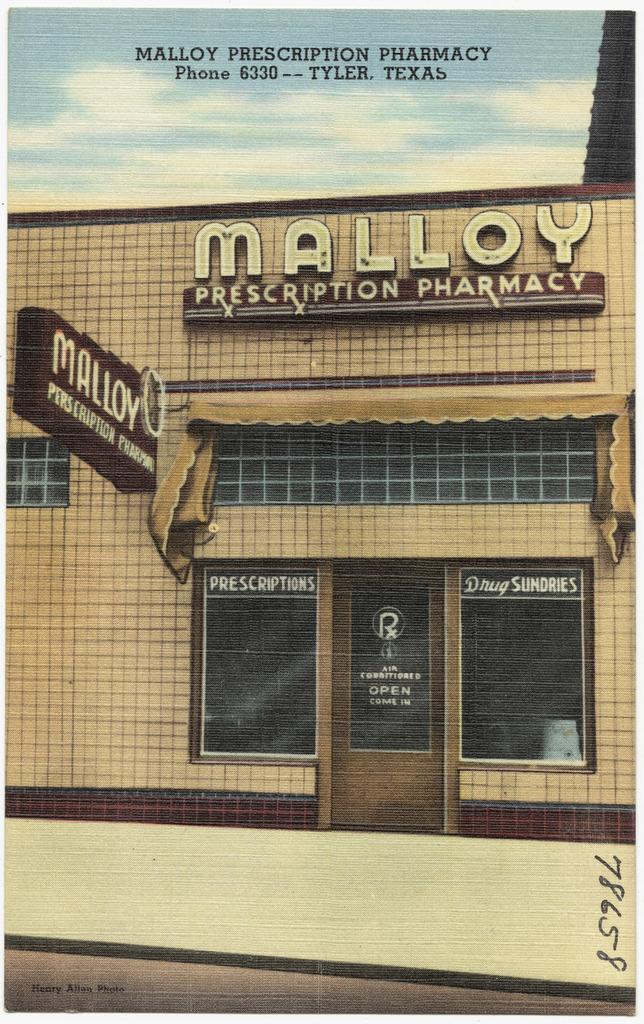What is depicted on the poster in the image? The poster contains a building. What features can be seen on the poster besides the building? The poster has boards, windows, and the sky with clouds. Is there any text present on the poster? No, there is no text on the poster. However, there is text written at the top of the image. How does the throat help solve the riddle on the poster? There is no riddle or mention of a throat on the poster. 